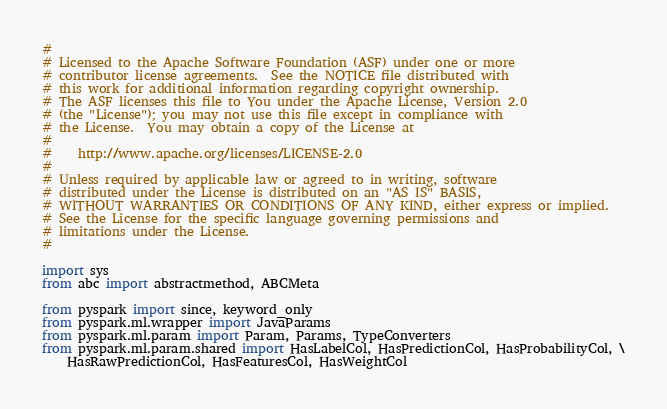<code> <loc_0><loc_0><loc_500><loc_500><_Python_>#
# Licensed to the Apache Software Foundation (ASF) under one or more
# contributor license agreements.  See the NOTICE file distributed with
# this work for additional information regarding copyright ownership.
# The ASF licenses this file to You under the Apache License, Version 2.0
# (the "License"); you may not use this file except in compliance with
# the License.  You may obtain a copy of the License at
#
#    http://www.apache.org/licenses/LICENSE-2.0
#
# Unless required by applicable law or agreed to in writing, software
# distributed under the License is distributed on an "AS IS" BASIS,
# WITHOUT WARRANTIES OR CONDITIONS OF ANY KIND, either express or implied.
# See the License for the specific language governing permissions and
# limitations under the License.
#

import sys
from abc import abstractmethod, ABCMeta

from pyspark import since, keyword_only
from pyspark.ml.wrapper import JavaParams
from pyspark.ml.param import Param, Params, TypeConverters
from pyspark.ml.param.shared import HasLabelCol, HasPredictionCol, HasProbabilityCol, \
    HasRawPredictionCol, HasFeaturesCol, HasWeightCol</code> 